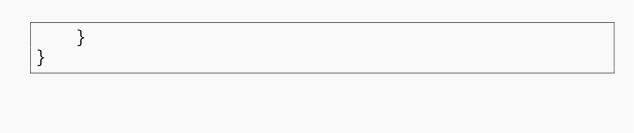<code> <loc_0><loc_0><loc_500><loc_500><_Java_>    }
}
</code> 